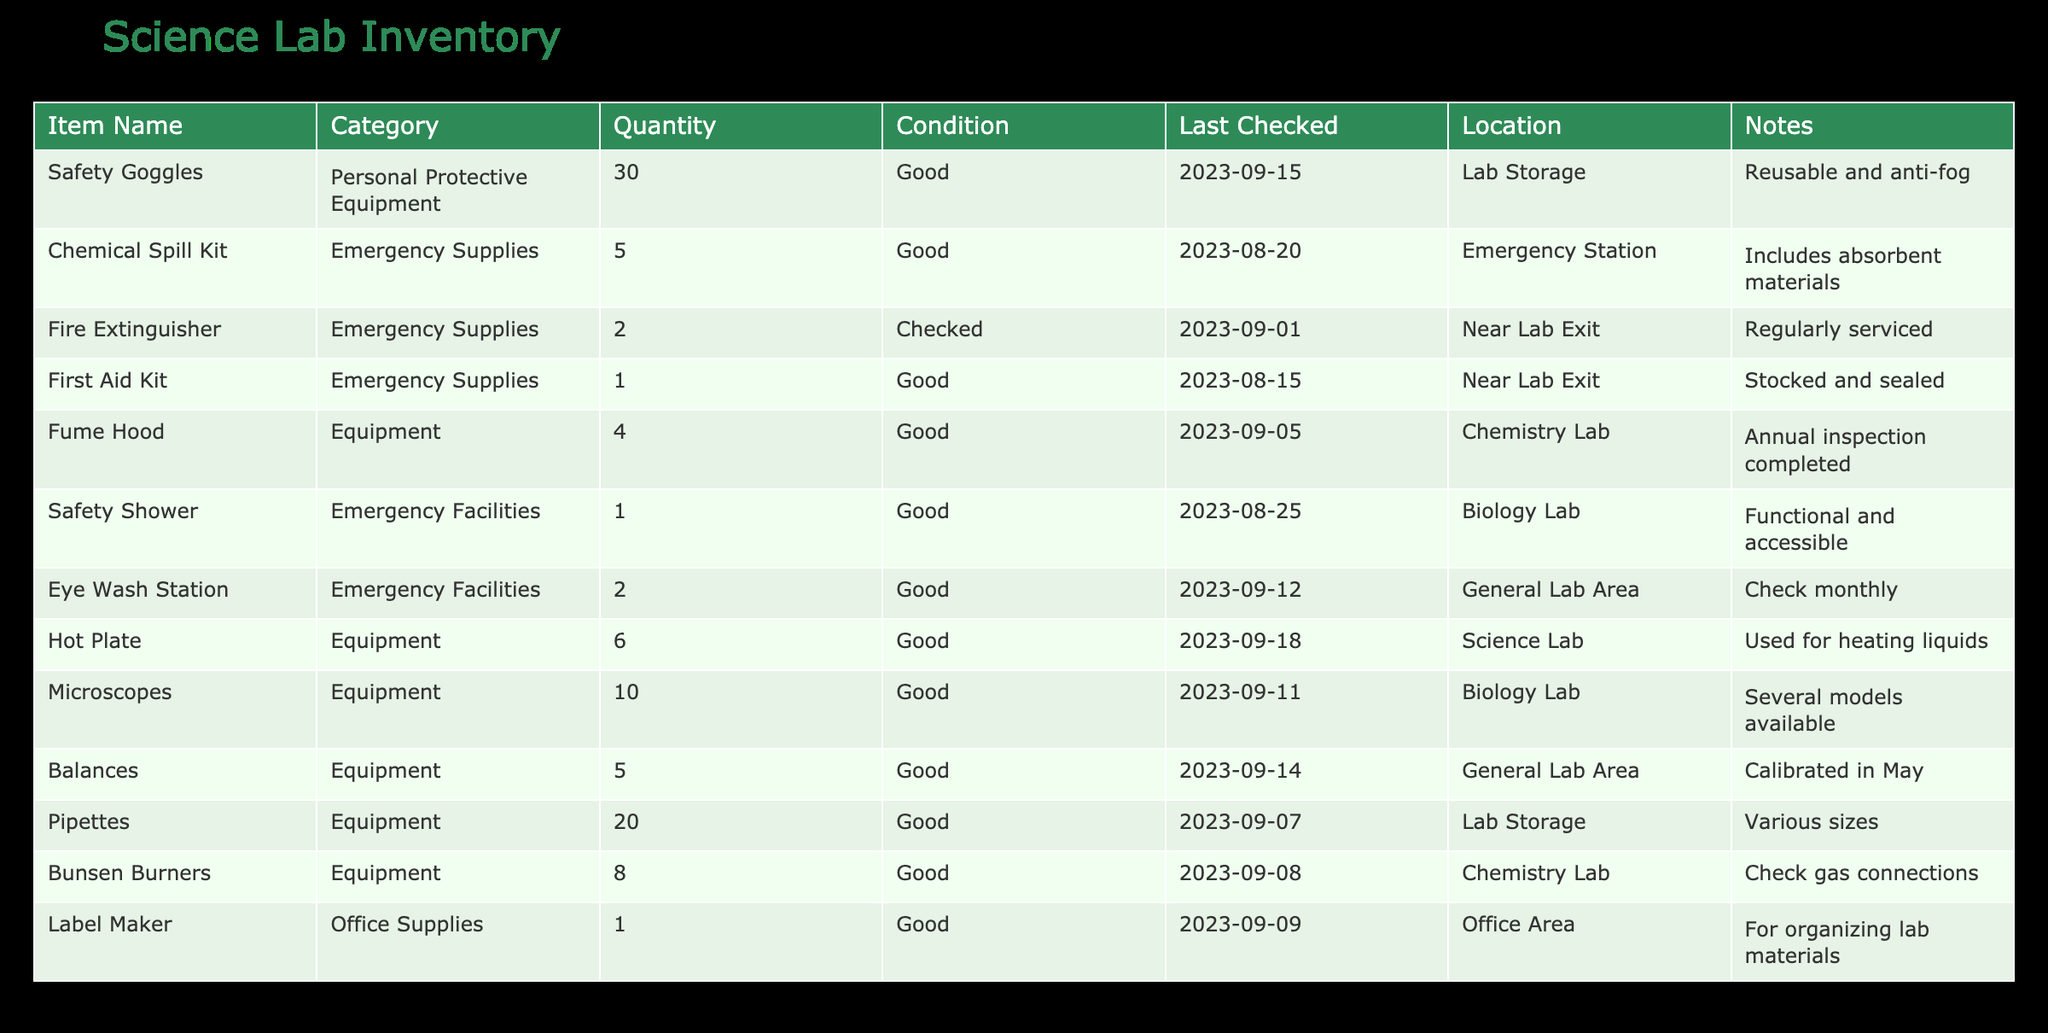What is the total quantity of Safety Goggles available? The table lists 30 pairs of Safety Goggles under the Quantity column. There are no additional entries for Safety Goggles, so the total quantity remains 30.
Answer: 30 How many Emergency Supplies are listed in the inventory? Looking at the table, there are three items categorized as Emergency Supplies: Chemical Spill Kit, Fire Extinguisher, and First Aid Kit. Therefore, the total count is 3.
Answer: 3 Are there more Fume Hoods than Safety Showers in the inventory? There are 4 Fume Hoods and 1 Safety Shower listed in the table. Since 4 is greater than 1, the answer is yes.
Answer: Yes What is the average quantity of Equipment items listed? The table indicates there are 6 distinct Equipment items: Fume Hood (4), Hot Plate (6), Microscopes (10), Balances (5), Pipettes (20), and Bunsen Burners (8). To find the average, sum them up: 4 + 6 + 10 + 5 + 20 + 8 = 53. Then divide by the number of items: 53/6 = approximately 8.83.
Answer: 8.83 Which item has the most quantity and how many are there? By comparing the quantities listed, Pipettes have the highest quantity at 20. No other items surpassed this count.
Answer: Pipettes, 20 